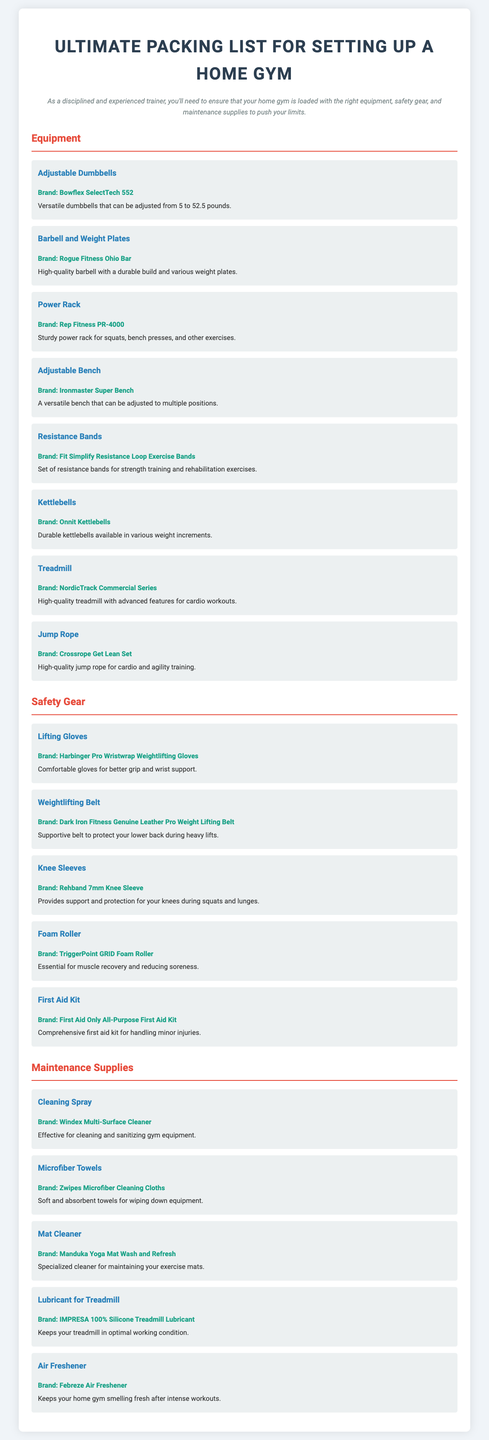what equipment is listed for strength training? The equipment listed for strength training includes Adjustable Dumbbells, Barbell and Weight Plates, Power Rack, Adjustable Bench, and Resistance Bands.
Answer: Adjustable Dumbbells, Barbell and Weight Plates, Power Rack, Adjustable Bench, Resistance Bands what brand is recommended for kettlebells? The brand recommended for kettlebells in the document is Onnit.
Answer: Onnit which safety gear is included for wrist support? The safety gear included for wrist support is Lifting Gloves.
Answer: Lifting Gloves how many items are listed under maintenance supplies? The total number of items listed under maintenance supplies, which include Cleaning Spray, Microfiber Towels, Mat Cleaner, Lubricant for Treadmill, and Air Freshener, is five.
Answer: five what is the purpose of a foam roller? The purpose of a foam roller is for muscle recovery and reducing soreness.
Answer: muscle recovery and reducing soreness which treadmill brand is mentioned? The brand mentioned for the treadmill is NordicTrack.
Answer: NordicTrack how many types of safety gear are listed? The types of safety gear listed include Lifting Gloves, Weightlifting Belt, Knee Sleeves, Foam Roller, and First Aid Kit, totaling five items.
Answer: five items 